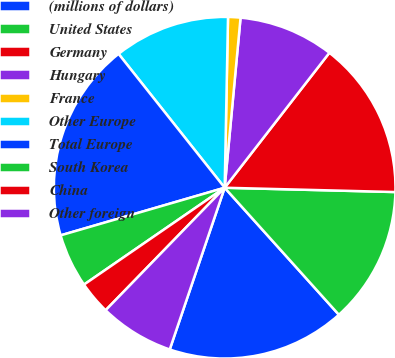Convert chart. <chart><loc_0><loc_0><loc_500><loc_500><pie_chart><fcel>(millions of dollars)<fcel>United States<fcel>Germany<fcel>Hungary<fcel>France<fcel>Other Europe<fcel>Total Europe<fcel>South Korea<fcel>China<fcel>Other foreign<nl><fcel>16.87%<fcel>12.94%<fcel>14.9%<fcel>9.02%<fcel>1.17%<fcel>10.98%<fcel>18.83%<fcel>5.1%<fcel>3.13%<fcel>7.06%<nl></chart> 